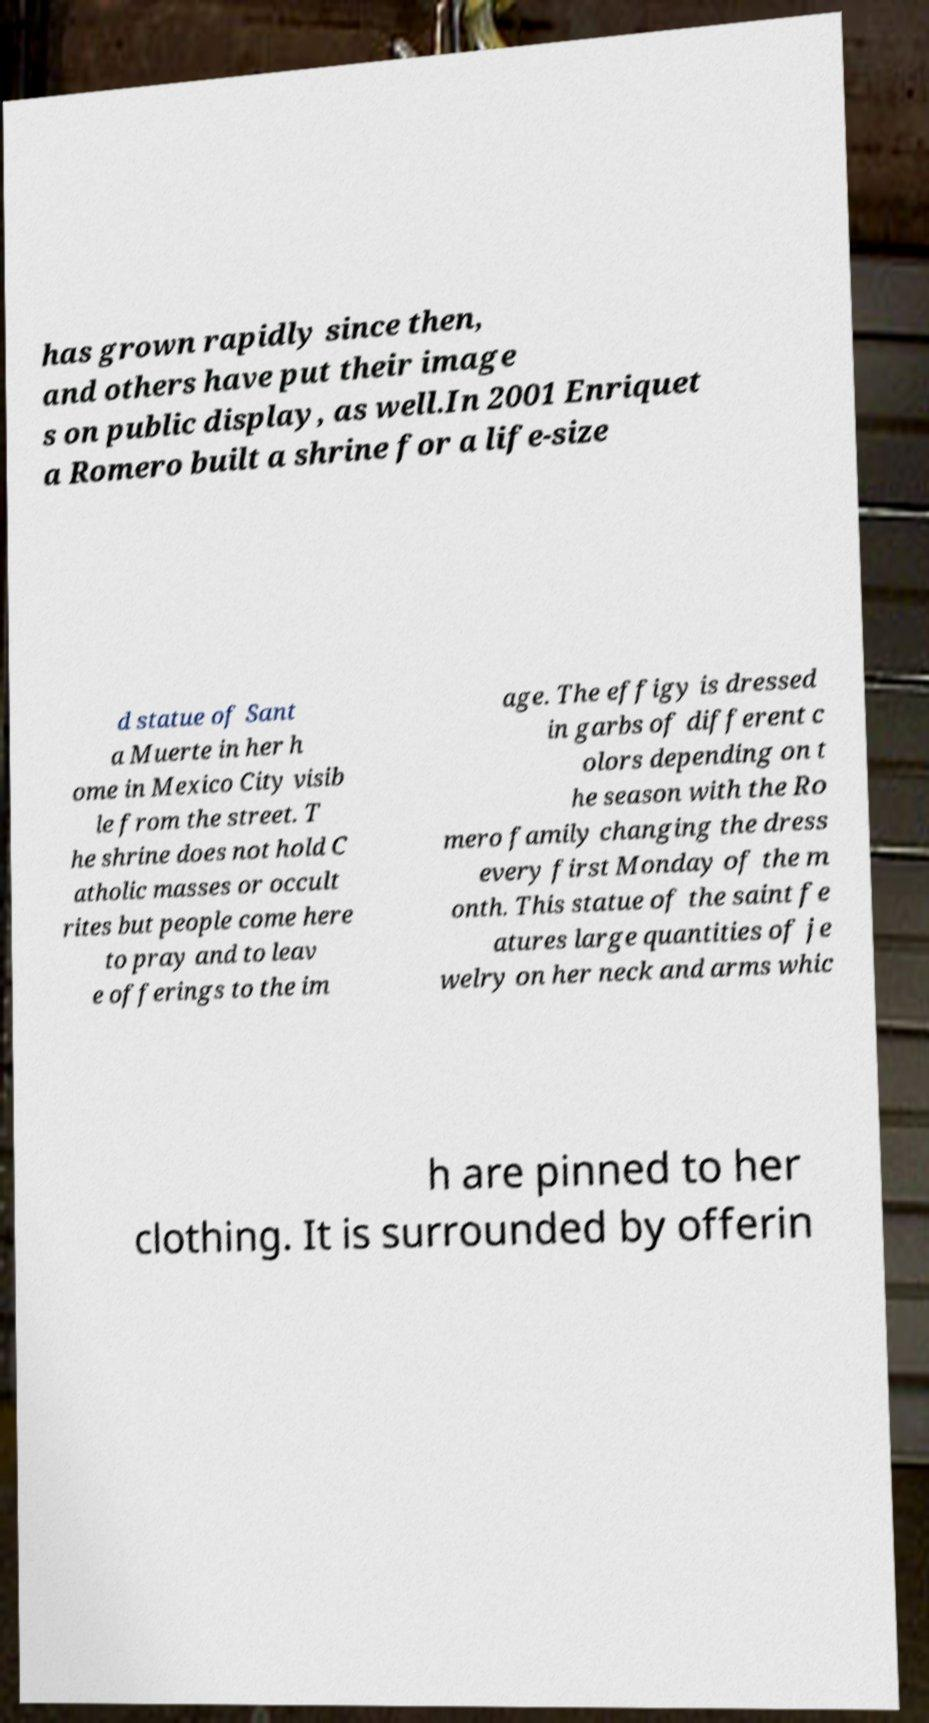Please read and relay the text visible in this image. What does it say? has grown rapidly since then, and others have put their image s on public display, as well.In 2001 Enriquet a Romero built a shrine for a life-size d statue of Sant a Muerte in her h ome in Mexico City visib le from the street. T he shrine does not hold C atholic masses or occult rites but people come here to pray and to leav e offerings to the im age. The effigy is dressed in garbs of different c olors depending on t he season with the Ro mero family changing the dress every first Monday of the m onth. This statue of the saint fe atures large quantities of je welry on her neck and arms whic h are pinned to her clothing. It is surrounded by offerin 